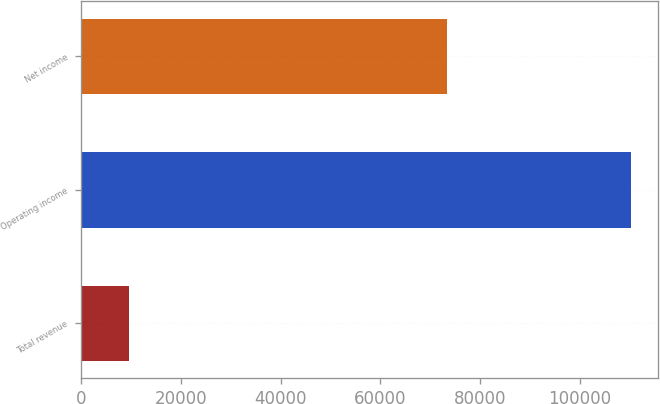<chart> <loc_0><loc_0><loc_500><loc_500><bar_chart><fcel>Total revenue<fcel>Operating income<fcel>Net income<nl><fcel>9636<fcel>110290<fcel>73304<nl></chart> 